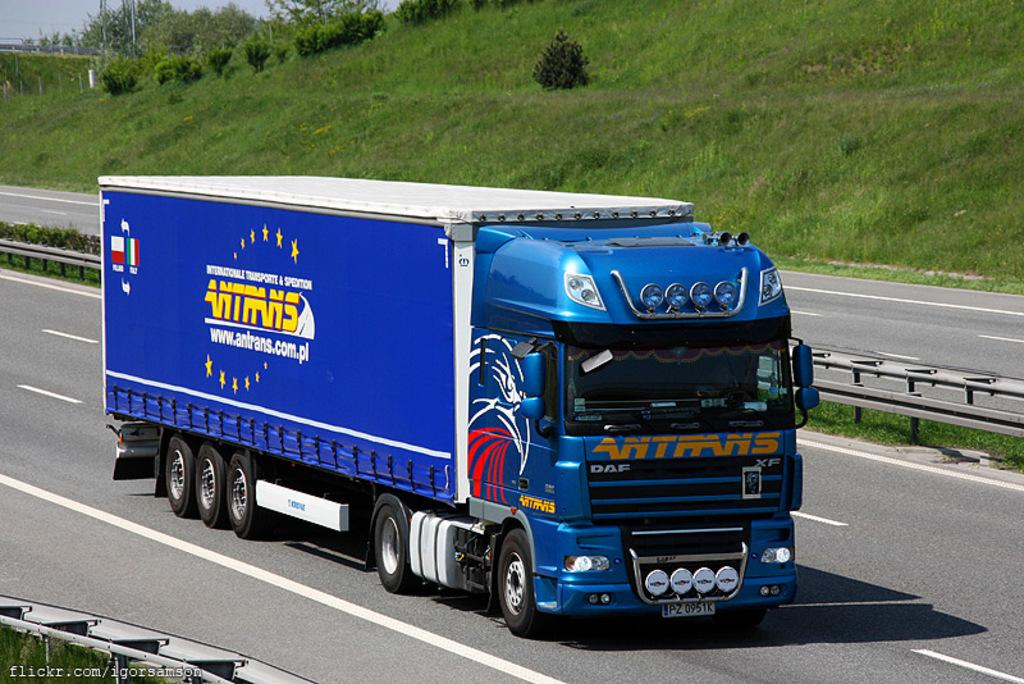What is on the road in the image? There is a vehicle on the road in the image. What is located next to the road in the image? There is a railing next to the road in the image. What type of vegetation is visible next to the road in the image? Grass is visible next to the road in the image. What can be seen in the background of the image? There are many trees and the sky is visible in the background of the image. What type of jeans is the tree wearing in the image? There are no jeans present in the image, as trees do not wear clothing. 